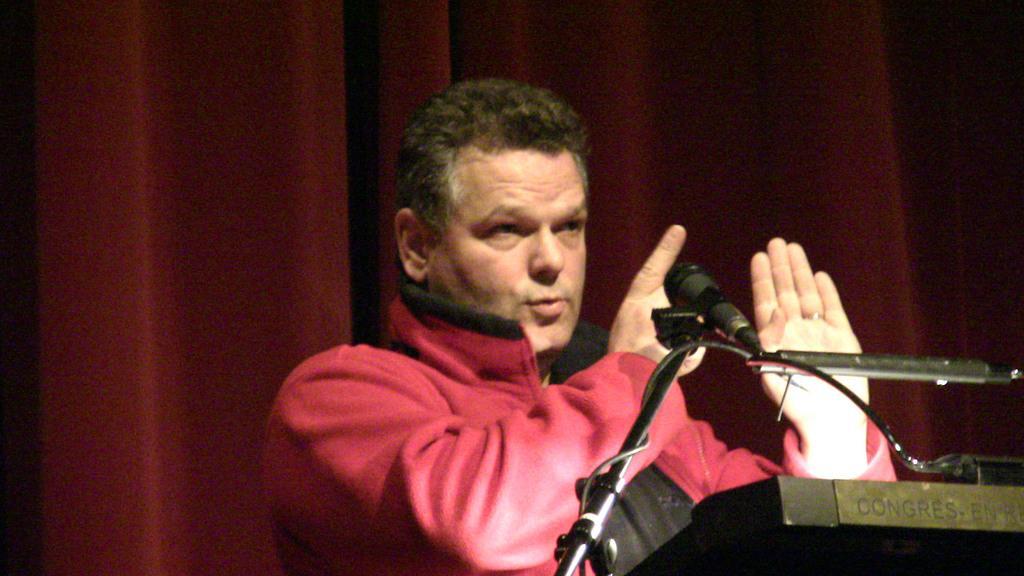In one or two sentences, can you explain what this image depicts? In this image there is a person standing near the podium, there is a microphone to the stand. 